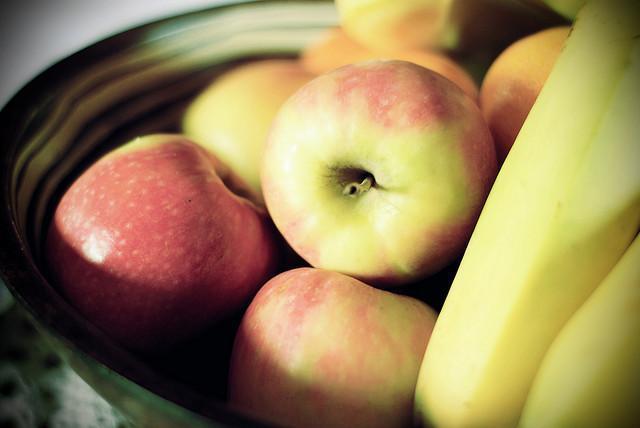How many different types of fruit are there?
Give a very brief answer. 3. How many oranges are visible?
Give a very brief answer. 3. How many bananas can be seen?
Give a very brief answer. 2. How many apples are in the picture?
Give a very brief answer. 2. 